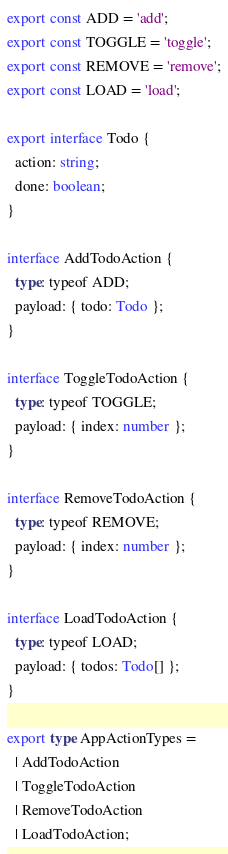<code> <loc_0><loc_0><loc_500><loc_500><_TypeScript_>export const ADD = 'add';
export const TOGGLE = 'toggle';
export const REMOVE = 'remove';
export const LOAD = 'load';

export interface Todo {
  action: string;
  done: boolean;
}

interface AddTodoAction {
  type: typeof ADD;
  payload: { todo: Todo };
}

interface ToggleTodoAction {
  type: typeof TOGGLE;
  payload: { index: number };
}

interface RemoveTodoAction {
  type: typeof REMOVE;
  payload: { index: number };
}

interface LoadTodoAction {
  type: typeof LOAD;
  payload: { todos: Todo[] };
}

export type AppActionTypes =
  | AddTodoAction
  | ToggleTodoAction
  | RemoveTodoAction
  | LoadTodoAction;
</code> 